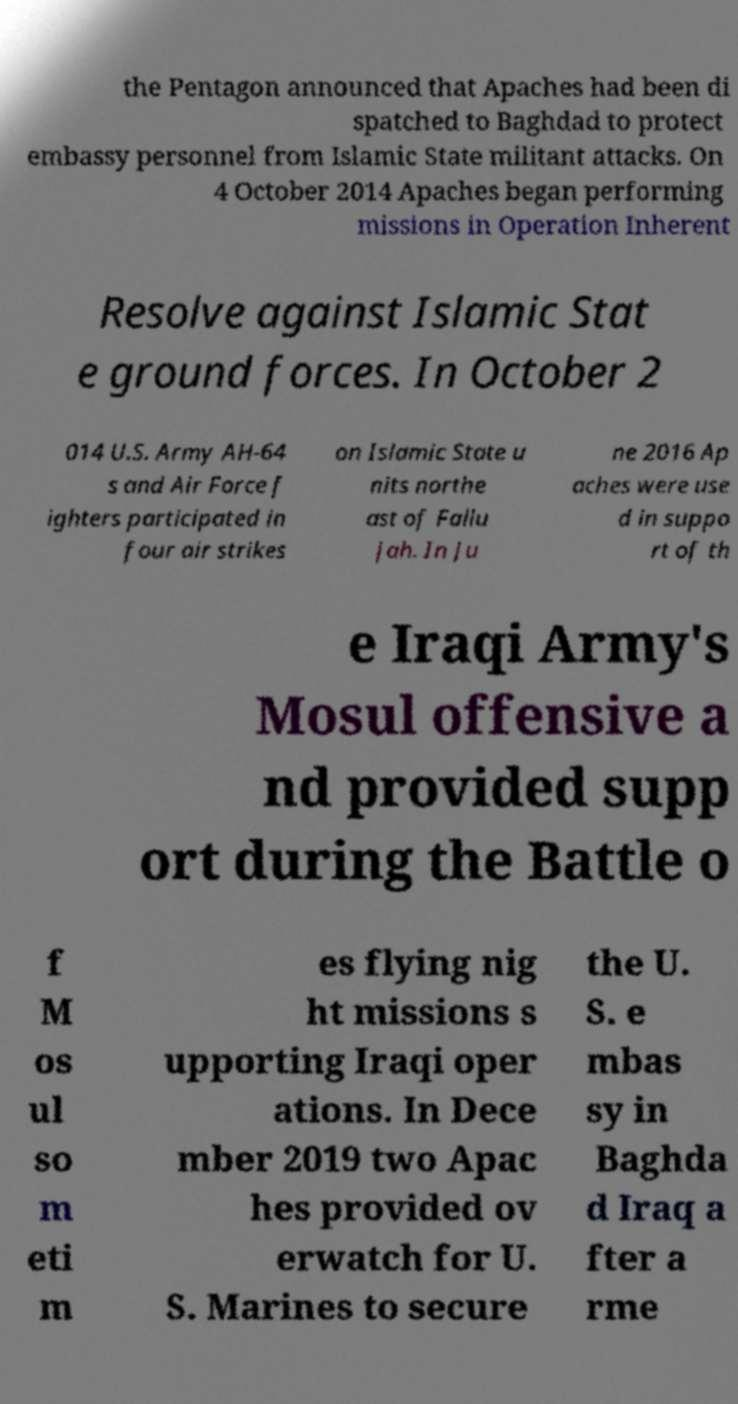There's text embedded in this image that I need extracted. Can you transcribe it verbatim? the Pentagon announced that Apaches had been di spatched to Baghdad to protect embassy personnel from Islamic State militant attacks. On 4 October 2014 Apaches began performing missions in Operation Inherent Resolve against Islamic Stat e ground forces. In October 2 014 U.S. Army AH-64 s and Air Force f ighters participated in four air strikes on Islamic State u nits northe ast of Fallu jah. In Ju ne 2016 Ap aches were use d in suppo rt of th e Iraqi Army's Mosul offensive a nd provided supp ort during the Battle o f M os ul so m eti m es flying nig ht missions s upporting Iraqi oper ations. In Dece mber 2019 two Apac hes provided ov erwatch for U. S. Marines to secure the U. S. e mbas sy in Baghda d Iraq a fter a rme 